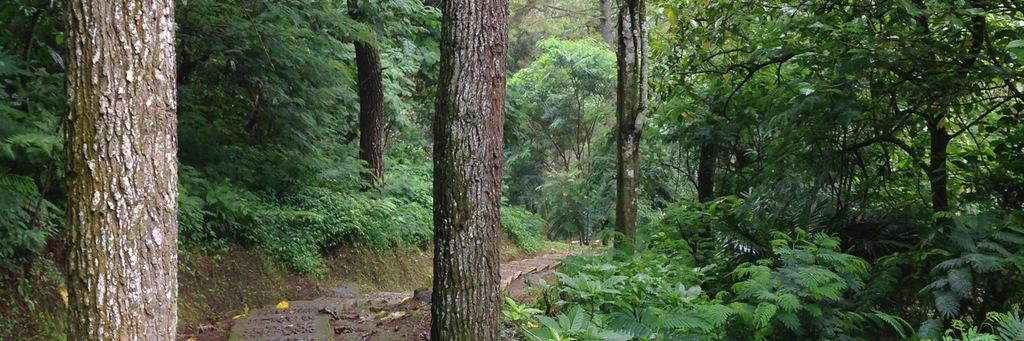What type of environment is shown in the image? The image depicts a forest. What can be found in abundance in the forest? There are many trees in the forest. Are there any other types of vegetation besides trees? Yes, there are plants in the forest. Is there a way to navigate through the forest? There is a path or way between the plants in the forest. What type of screw can be seen holding the pie in the air in the image? There is no screw or pie present in the image; it depicts a forest with trees, plants, and a path. 